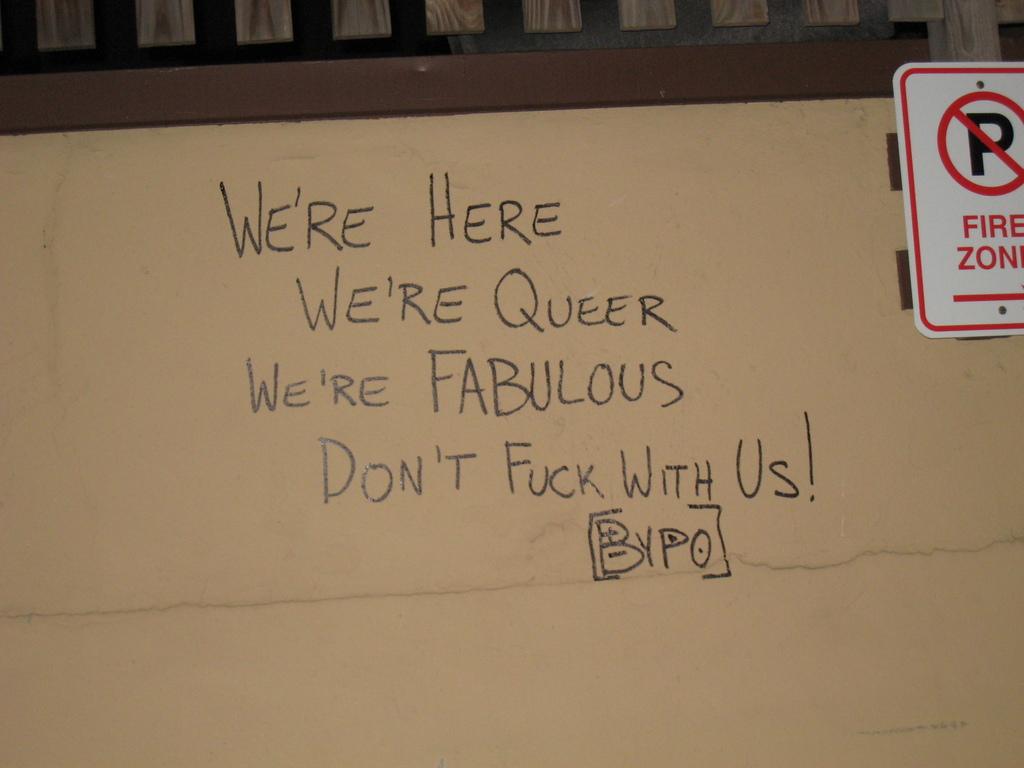What type of zone sign is displayed?
Offer a terse response. Fire. What does the sign in the top right hand corner mean?
Your answer should be very brief. No parking. 